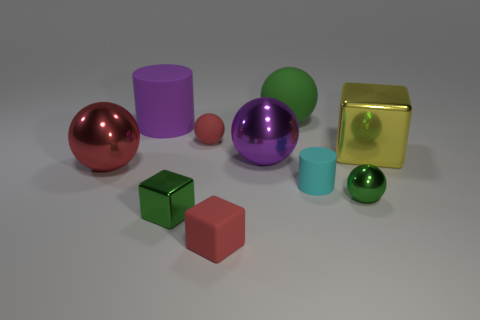Subtract all gray cylinders. How many red spheres are left? 2 Subtract all purple spheres. How many spheres are left? 4 Subtract 3 balls. How many balls are left? 2 Subtract all small cubes. How many cubes are left? 1 Subtract all blue spheres. Subtract all red cylinders. How many spheres are left? 5 Subtract all blocks. How many objects are left? 7 Add 7 gray shiny blocks. How many gray shiny blocks exist? 7 Subtract 0 brown blocks. How many objects are left? 10 Subtract all cyan rubber objects. Subtract all small green cubes. How many objects are left? 8 Add 5 yellow cubes. How many yellow cubes are left? 6 